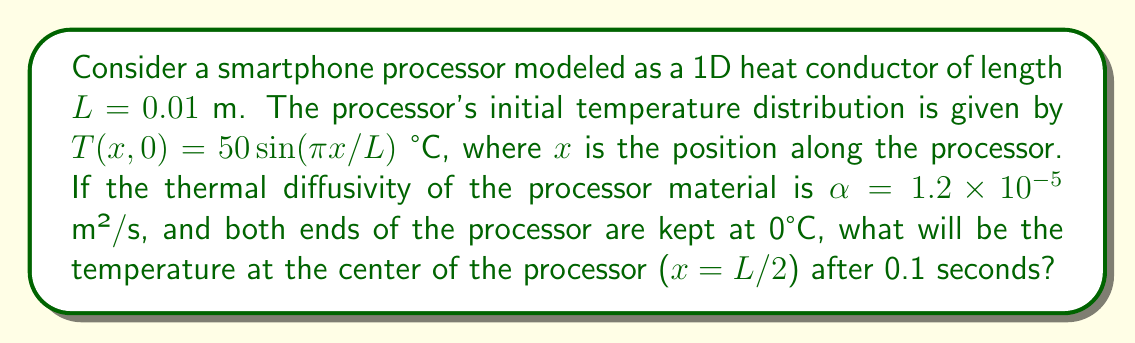Show me your answer to this math problem. To solve this problem, we'll use the 1D heat equation and apply the separation of variables method:

1) The 1D heat equation is:
   $$\frac{\partial T}{\partial t} = \alpha \frac{\partial^2 T}{\partial x^2}$$

2) Given boundary conditions: $T(0,t) = T(L,t) = 0$

3) Initial condition: $T(x,0) = 50 \sin(\pi x/L)$

4) The general solution for this problem is:
   $$T(x,t) = \sum_{n=1}^{\infty} B_n \sin(\frac{n\pi x}{L}) e^{-\alpha(\frac{n\pi}{L})^2t}$$

5) Comparing with the initial condition, we see that only n = 1 term is present, so:
   $$T(x,t) = 50 \sin(\frac{\pi x}{L}) e^{-\alpha(\frac{\pi}{L})^2t}$$

6) To find the temperature at the center (x = L/2) at t = 0.1 s:
   $$T(L/2, 0.1) = 50 \sin(\frac{\pi (L/2)}{L}) e^{-\alpha(\frac{\pi}{L})^2(0.1)}$$

7) Simplify:
   $$T(L/2, 0.1) = 50 \sin(\frac{\pi}{2}) e^{-\alpha(\frac{\pi}{0.01})^2(0.1)}$$

8) Calculate:
   $$T(L/2, 0.1) = 50 \cdot 1 \cdot e^{-(1.2 \times 10^{-5})(\frac{\pi}{0.01})^2(0.1)}$$
   $$= 50 e^{-11.8} \approx 0.38 \text{ °C}$$
Answer: 0.38 °C 